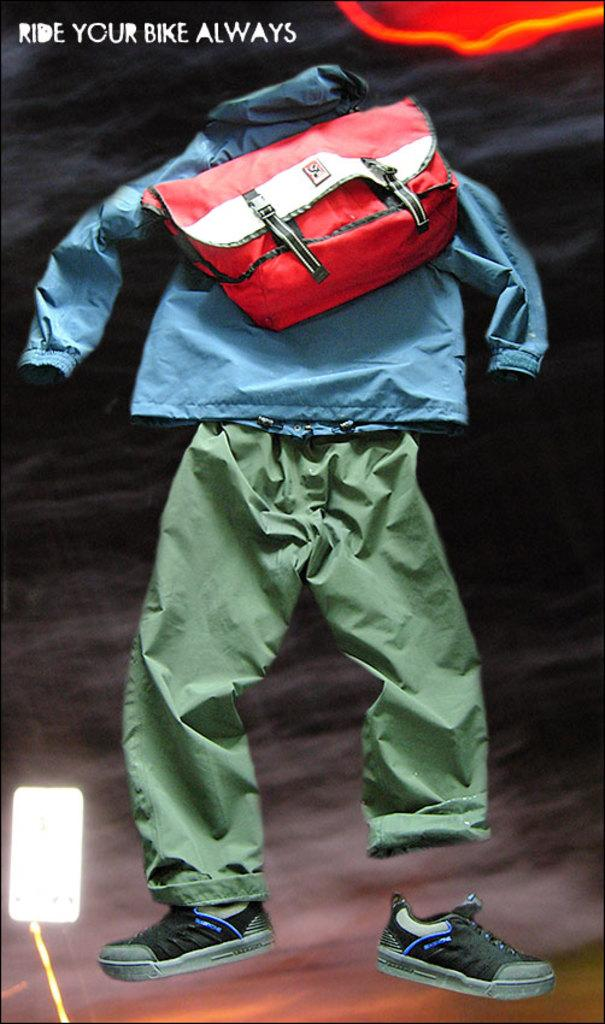What type of items can be seen in the image? There are clothes, a bag, and shoes in the image. Can you describe the light in the image? There is a light present in the image. What type of baseball equipment can be seen in the image? There is no baseball equipment present in the image. How many hands are visible in the image? There is no mention of hands in the provided facts, so we cannot determine the number of hands visible in the image. 